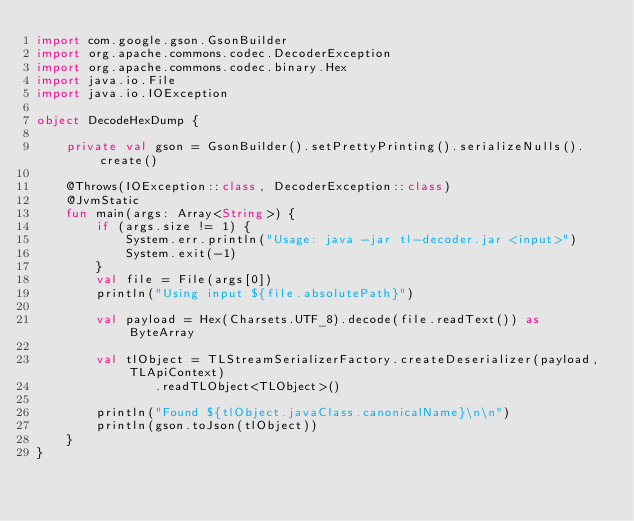<code> <loc_0><loc_0><loc_500><loc_500><_Kotlin_>import com.google.gson.GsonBuilder
import org.apache.commons.codec.DecoderException
import org.apache.commons.codec.binary.Hex
import java.io.File
import java.io.IOException

object DecodeHexDump {

    private val gson = GsonBuilder().setPrettyPrinting().serializeNulls().create()

    @Throws(IOException::class, DecoderException::class)
    @JvmStatic
    fun main(args: Array<String>) {
        if (args.size != 1) {
            System.err.println("Usage: java -jar tl-decoder.jar <input>")
            System.exit(-1)
        }
        val file = File(args[0])
        println("Using input ${file.absolutePath}")

        val payload = Hex(Charsets.UTF_8).decode(file.readText()) as ByteArray

        val tlObject = TLStreamSerializerFactory.createDeserializer(payload, TLApiContext)
                .readTLObject<TLObject>()

        println("Found ${tlObject.javaClass.canonicalName}\n\n")
        println(gson.toJson(tlObject))
    }
}
</code> 